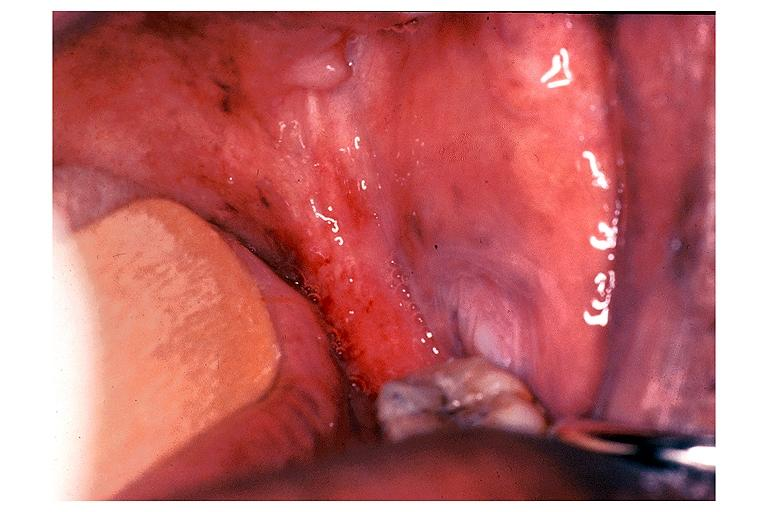what is present?
Answer the question using a single word or phrase. Oral 